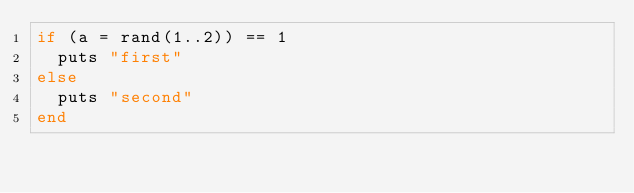Convert code to text. <code><loc_0><loc_0><loc_500><loc_500><_Ruby_>if (a = rand(1..2)) == 1
  puts "first"
else
  puts "second"
end</code> 